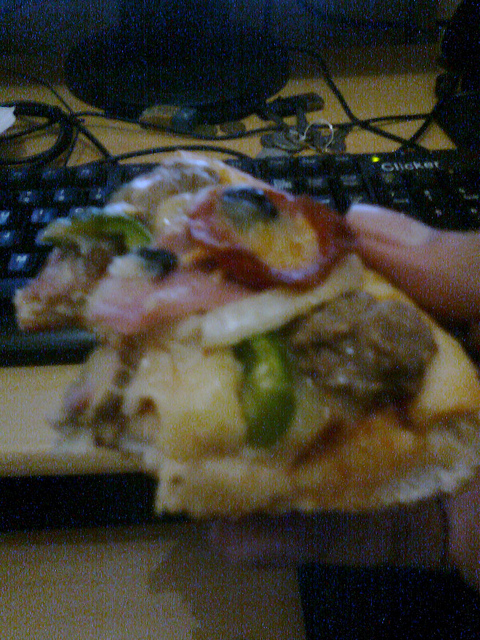What kind of food is this? This is a pizza topped with a variety of ingredients including pineapple, ham, and possibly mushrooms. 